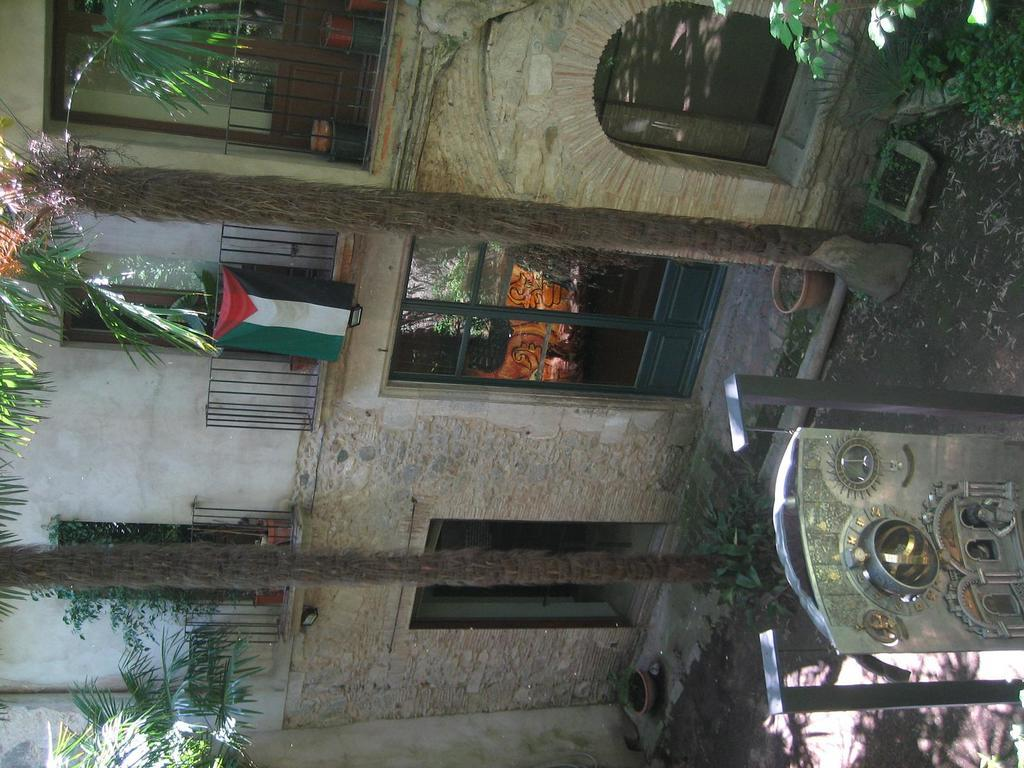What type of structure can be seen in the image? There is a building in the image. What is located near the building? There is a fence in the image. What national symbol is present in the image? There is a flag of a country in the image. What type of vegetation is visible in the image? There are trees in the image. What type of container is present in the image? There is a pot in the image. What type of terrain is visible in the image? There is sand in the image. What object is present in the image? There is an object in the image. What type of beetle can be seen crawling on the flag in the image? There is no beetle present on the flag or in the image. What type of friction is present between the building and the fence in the image? The image does not provide information about the friction between the building and the fence. 